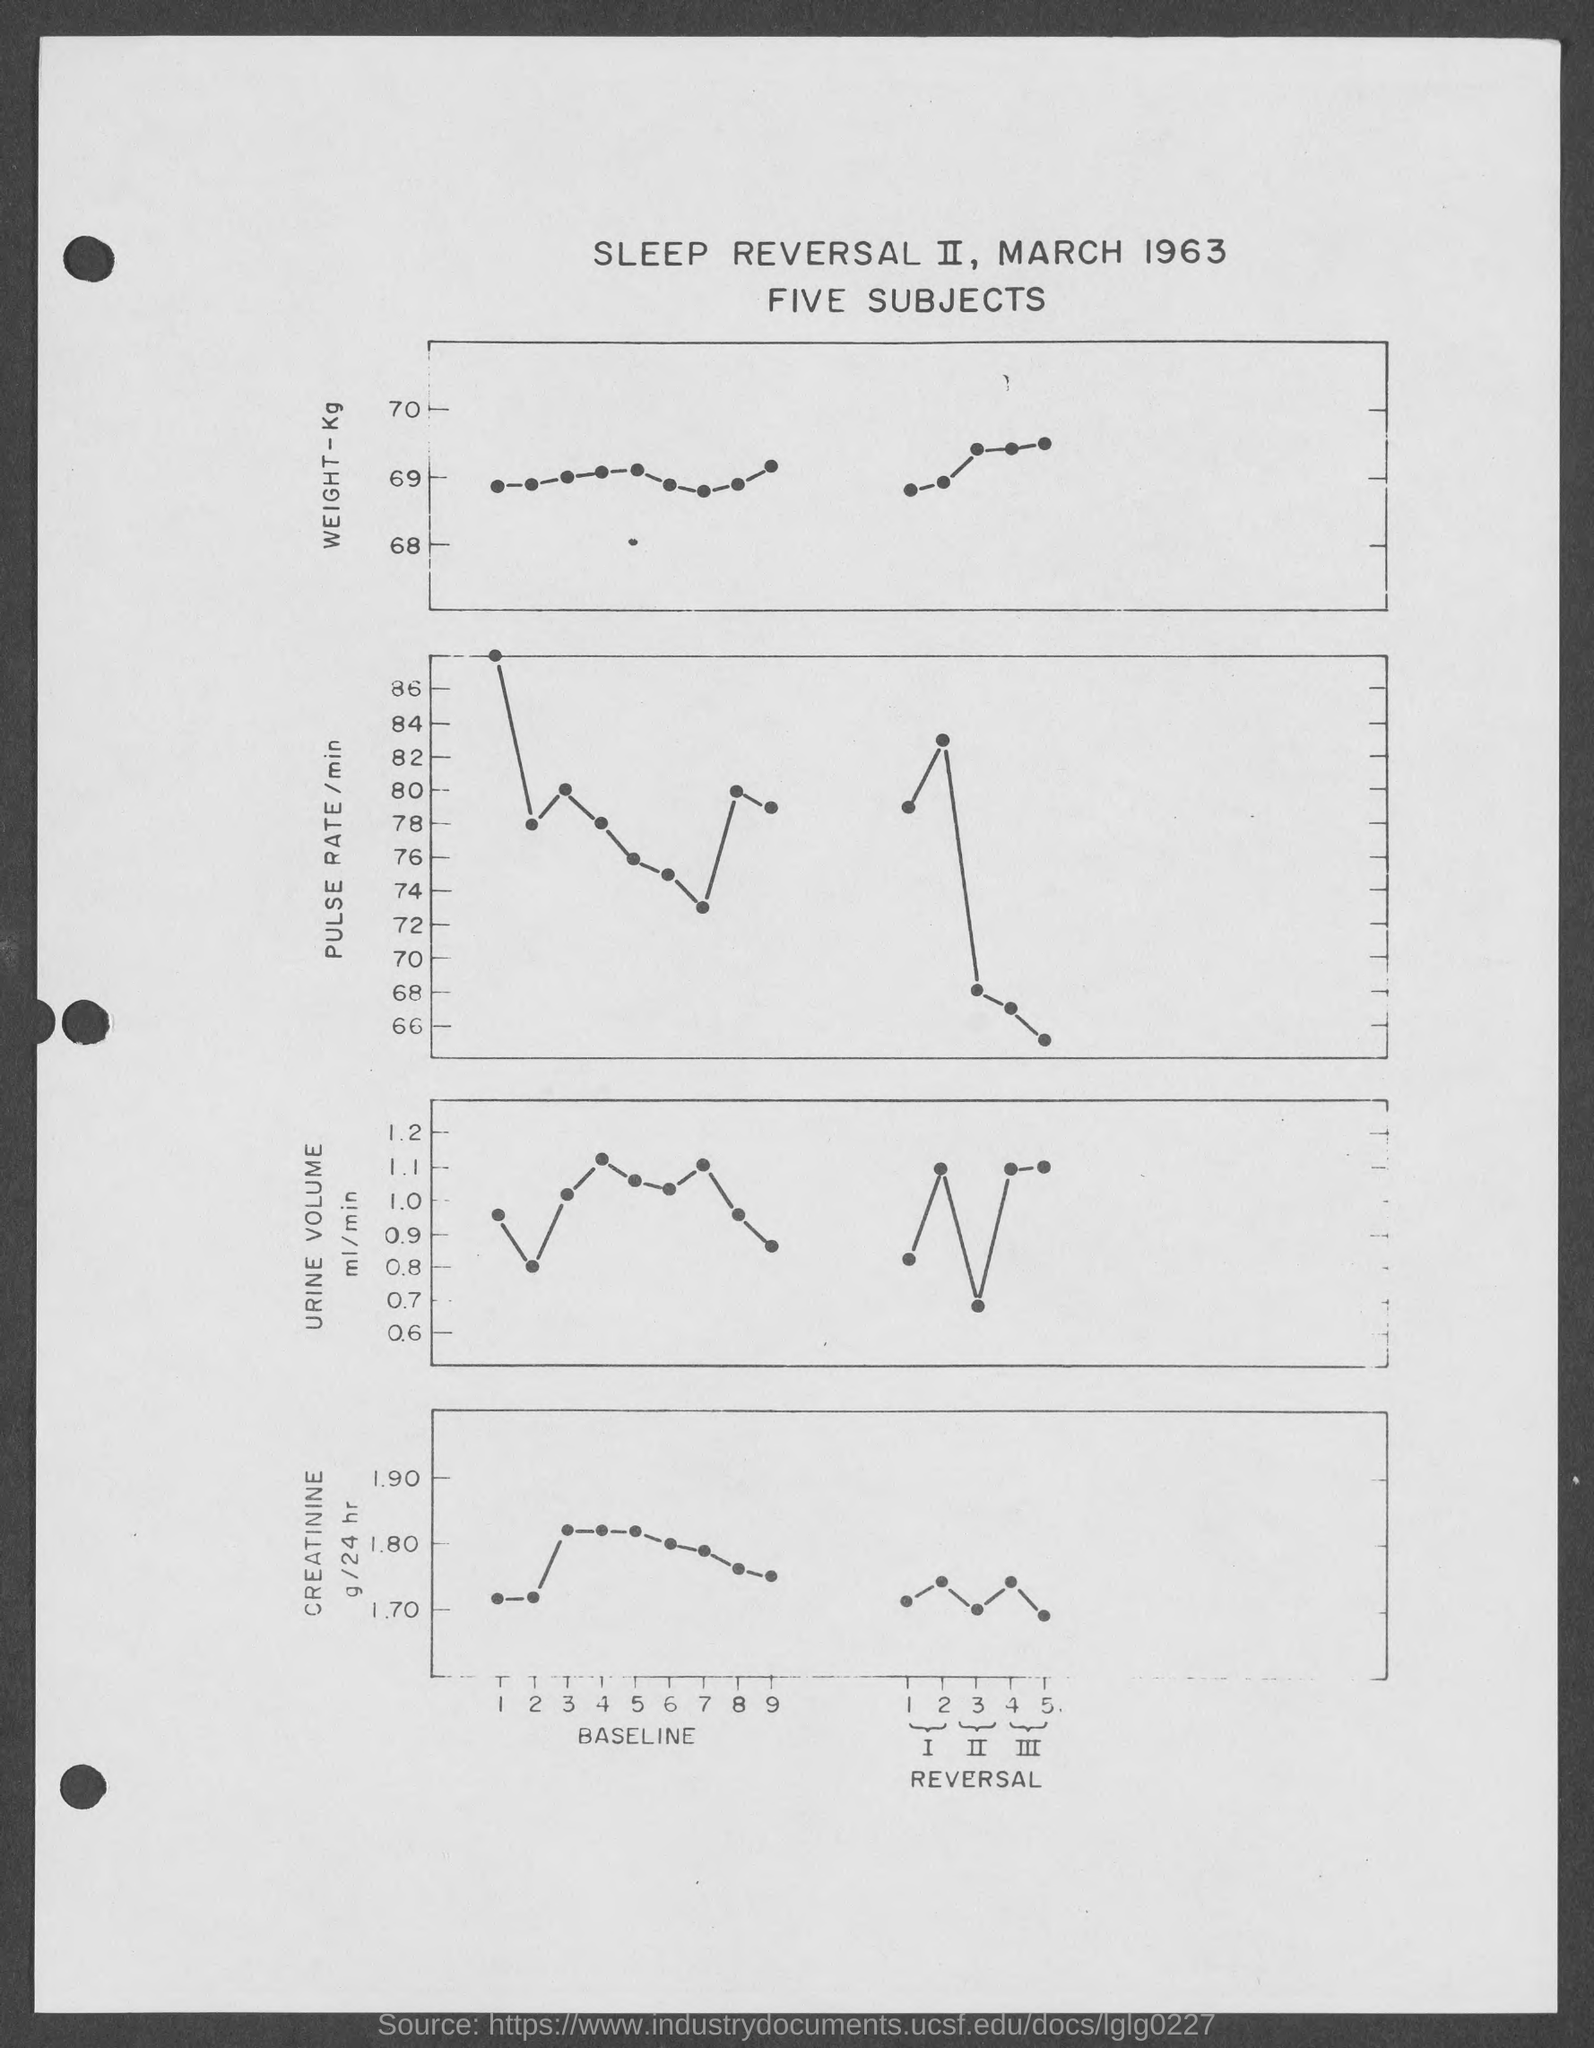Indicate a few pertinent items in this graphic. The date mentioned in the given page is March 1963. 